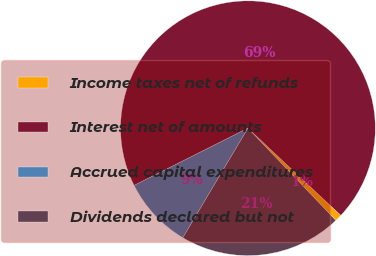Convert chart. <chart><loc_0><loc_0><loc_500><loc_500><pie_chart><fcel>Income taxes net of refunds<fcel>Interest net of amounts<fcel>Accrued capital expenditures<fcel>Dividends declared but not<nl><fcel>0.88%<fcel>69.41%<fcel>9.05%<fcel>20.66%<nl></chart> 